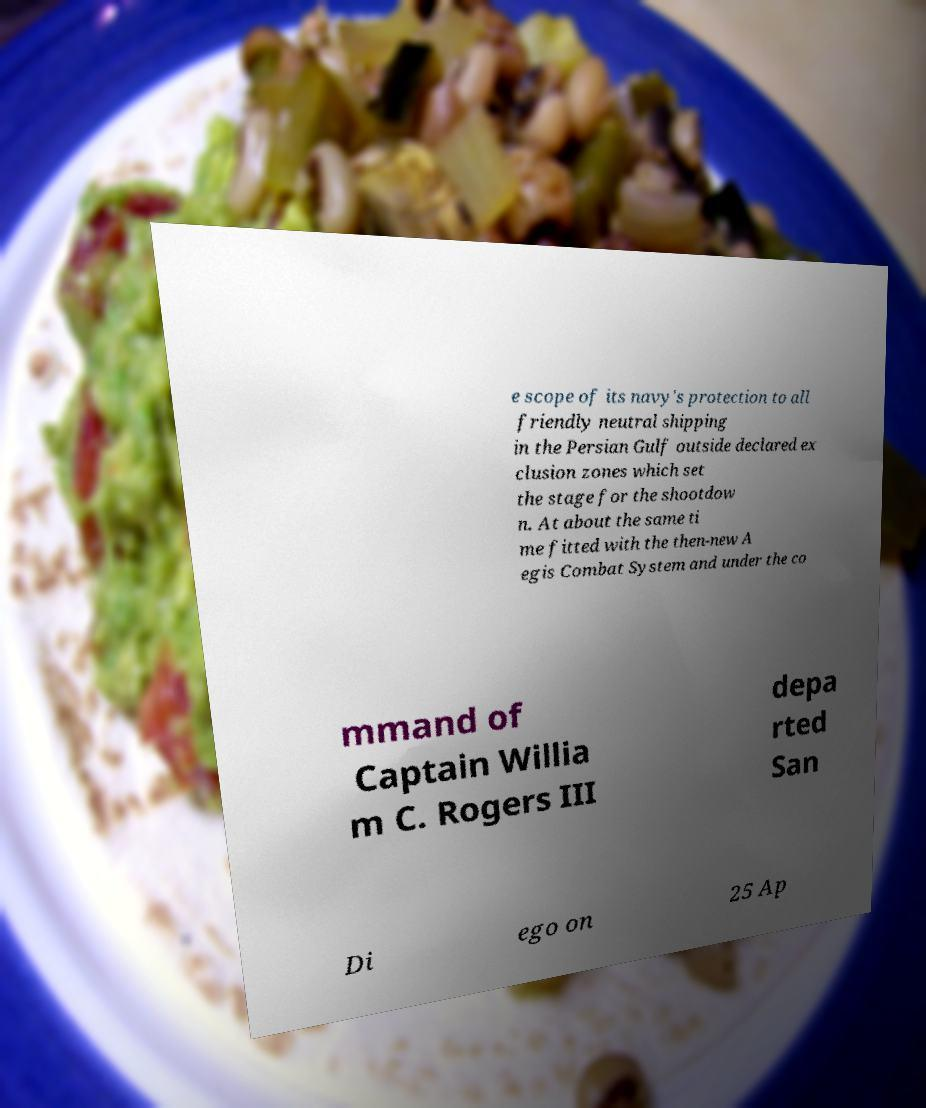I need the written content from this picture converted into text. Can you do that? e scope of its navy's protection to all friendly neutral shipping in the Persian Gulf outside declared ex clusion zones which set the stage for the shootdow n. At about the same ti me fitted with the then-new A egis Combat System and under the co mmand of Captain Willia m C. Rogers III depa rted San Di ego on 25 Ap 